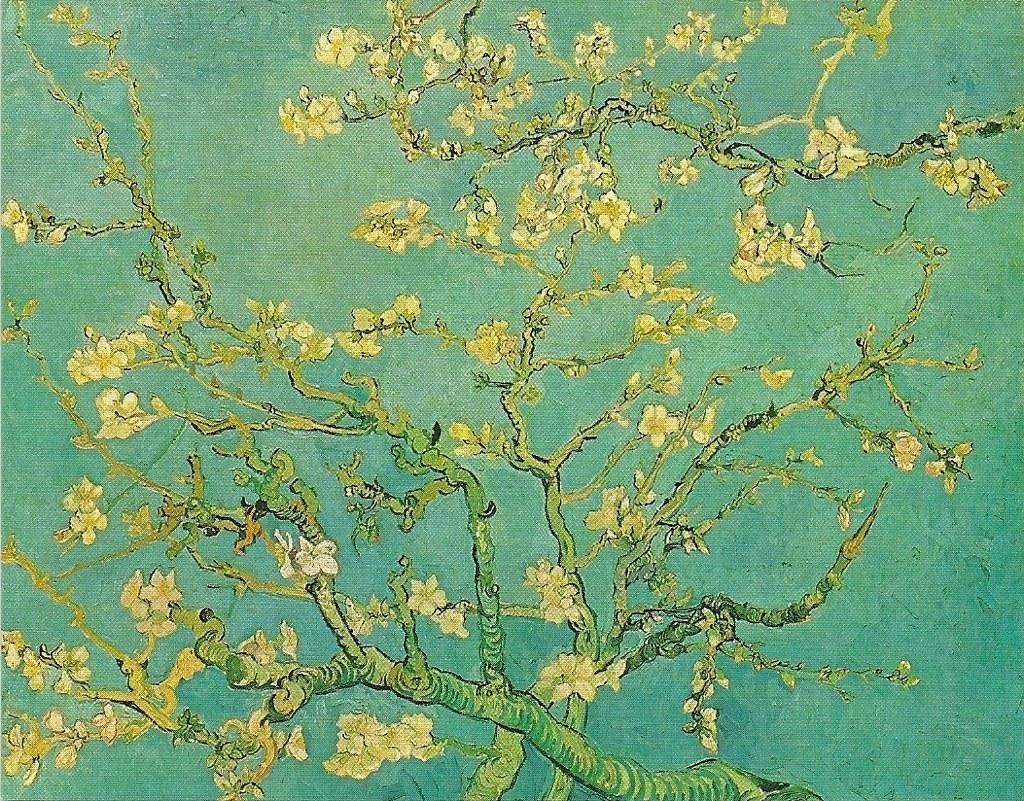What is the main subject of the image? There is a painting in the center of the image. What does the painting depict? The painting depicts branches with leaves. What is the tendency of the scarf in the image? There is no scarf present in the image, so it is not possible to determine its tendency. 